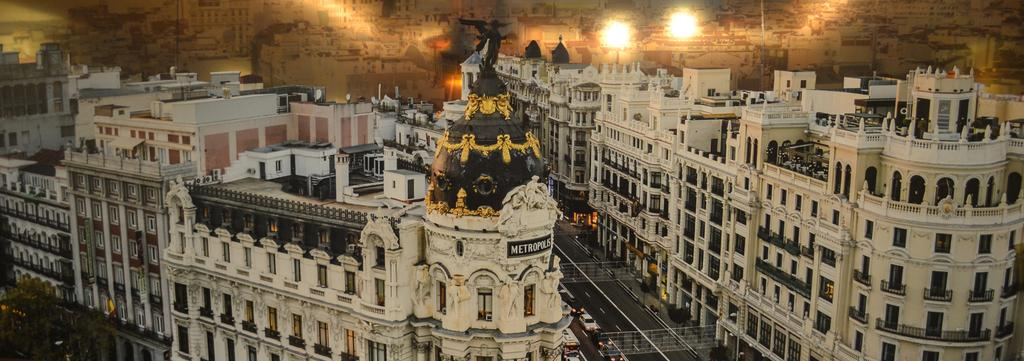What type of view is shown in the image? The image is an outside view. What structures can be seen in the image? There are many buildings visible in the image. What is at the bottom of the image? There is a road at the bottom of the image. What is on the road? There are cars on the road. What type of vegetation is near the road? There are trees beside the road. Where is the mint plant located in the image? There is no mint plant visible in the image. How many chickens are crossing the road in the image? There are no chickens present in the image. 